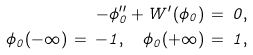Convert formula to latex. <formula><loc_0><loc_0><loc_500><loc_500>- \phi _ { 0 } ^ { \prime \prime } + W ^ { \prime } ( \phi _ { 0 } ) \, = \, 0 , \\ \phi _ { 0 } ( - \infty ) \, = \, - 1 , \quad \phi _ { 0 } ( + \infty ) \, = \, 1 ,</formula> 